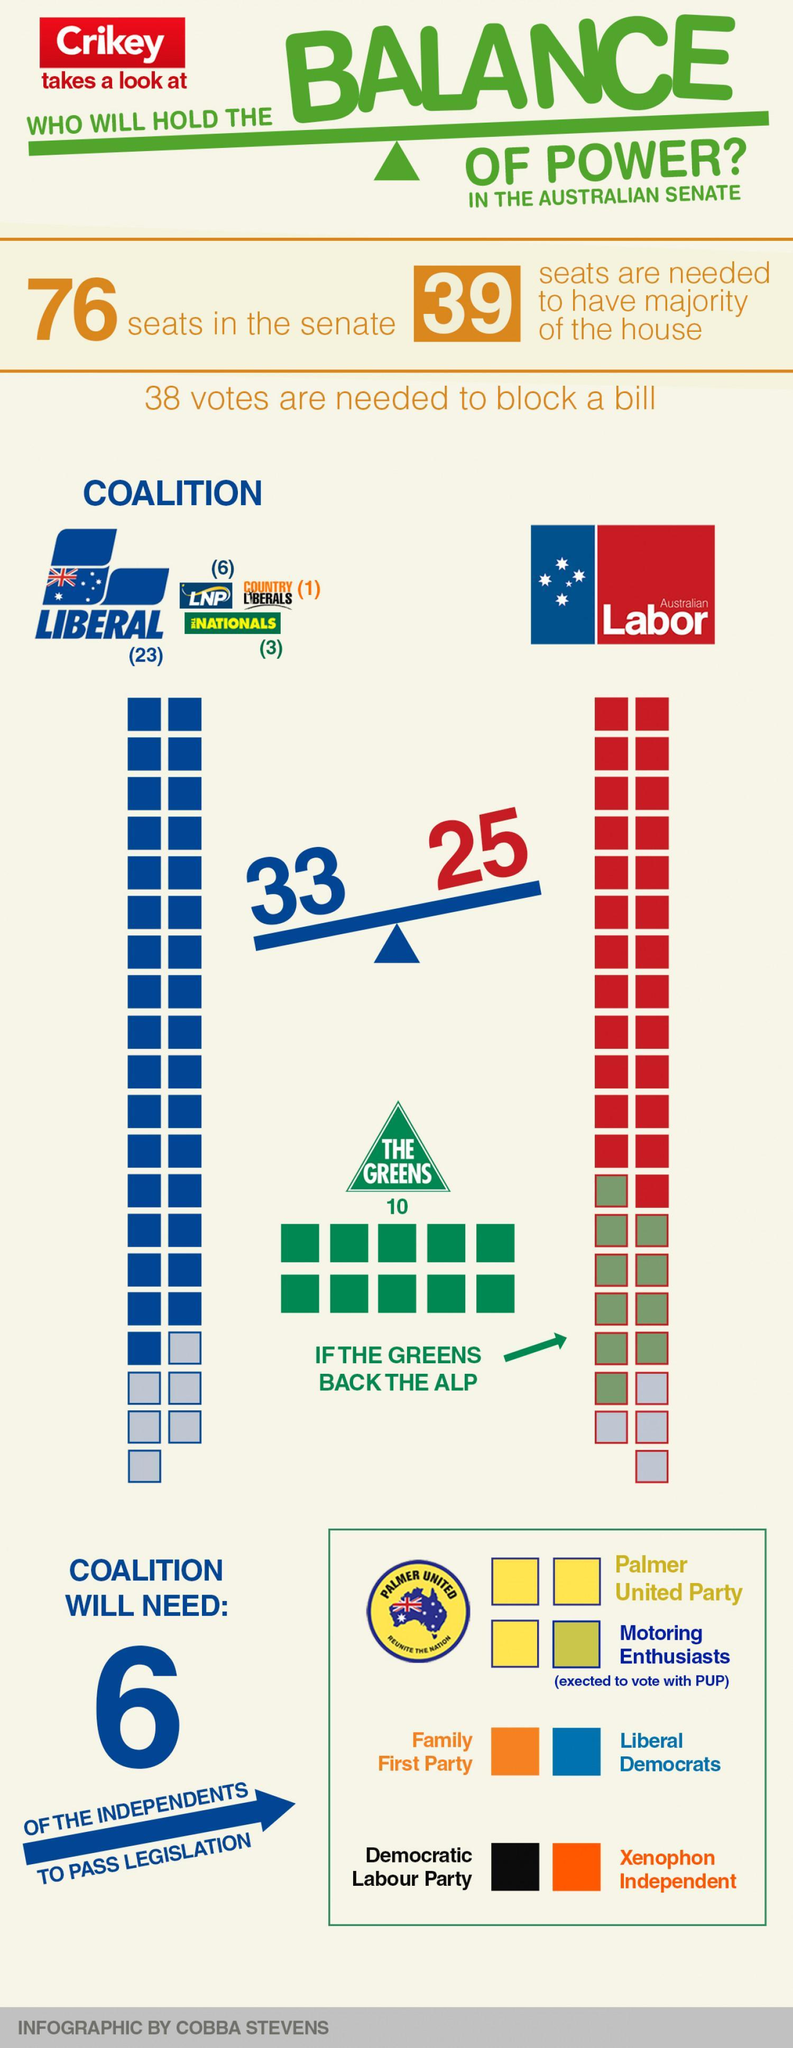How many seats did the coalition win?
Answer the question with a short phrase. 33 How many seats were won by Australian labor party? 25 How many seats did LNP get? 6 Which party has majority of seats in the coalition? Liberal How many seats did Liberal party get? 23 Who is likely to support the ALP? The Greens 